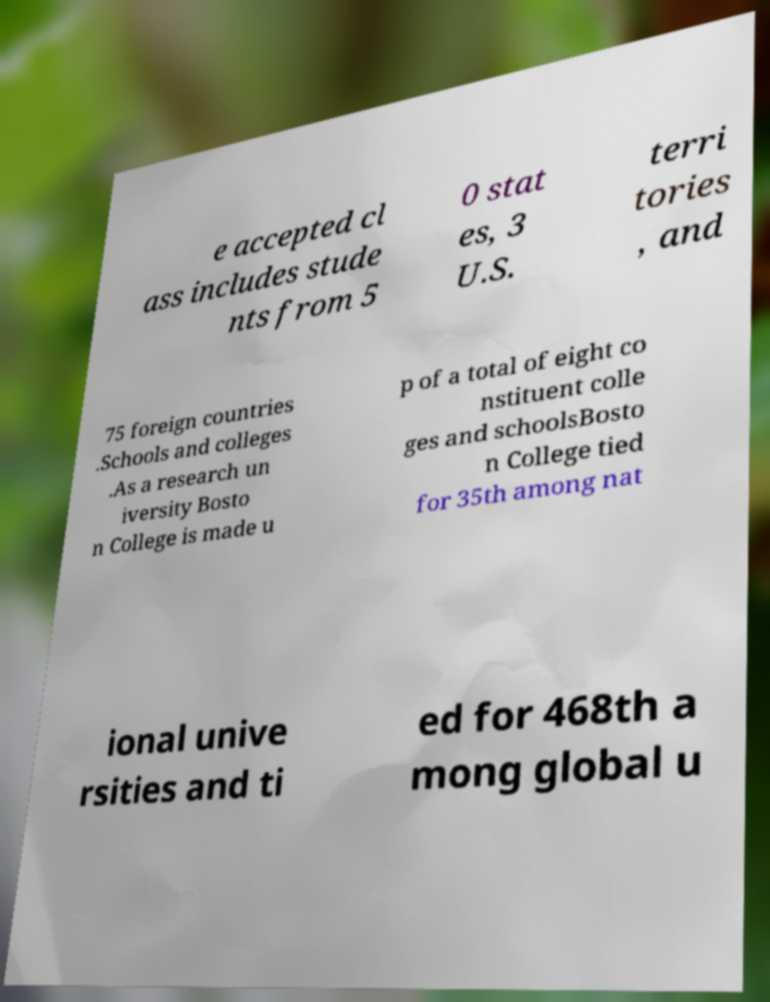For documentation purposes, I need the text within this image transcribed. Could you provide that? e accepted cl ass includes stude nts from 5 0 stat es, 3 U.S. terri tories , and 75 foreign countries .Schools and colleges .As a research un iversity Bosto n College is made u p of a total of eight co nstituent colle ges and schoolsBosto n College tied for 35th among nat ional unive rsities and ti ed for 468th a mong global u 